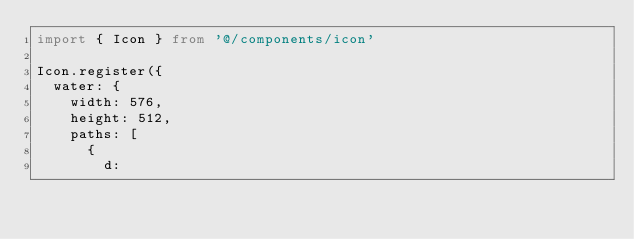Convert code to text. <code><loc_0><loc_0><loc_500><loc_500><_TypeScript_>import { Icon } from '@/components/icon'

Icon.register({
  water: {
    width: 576,
    height: 512,
    paths: [
      {
        d:</code> 